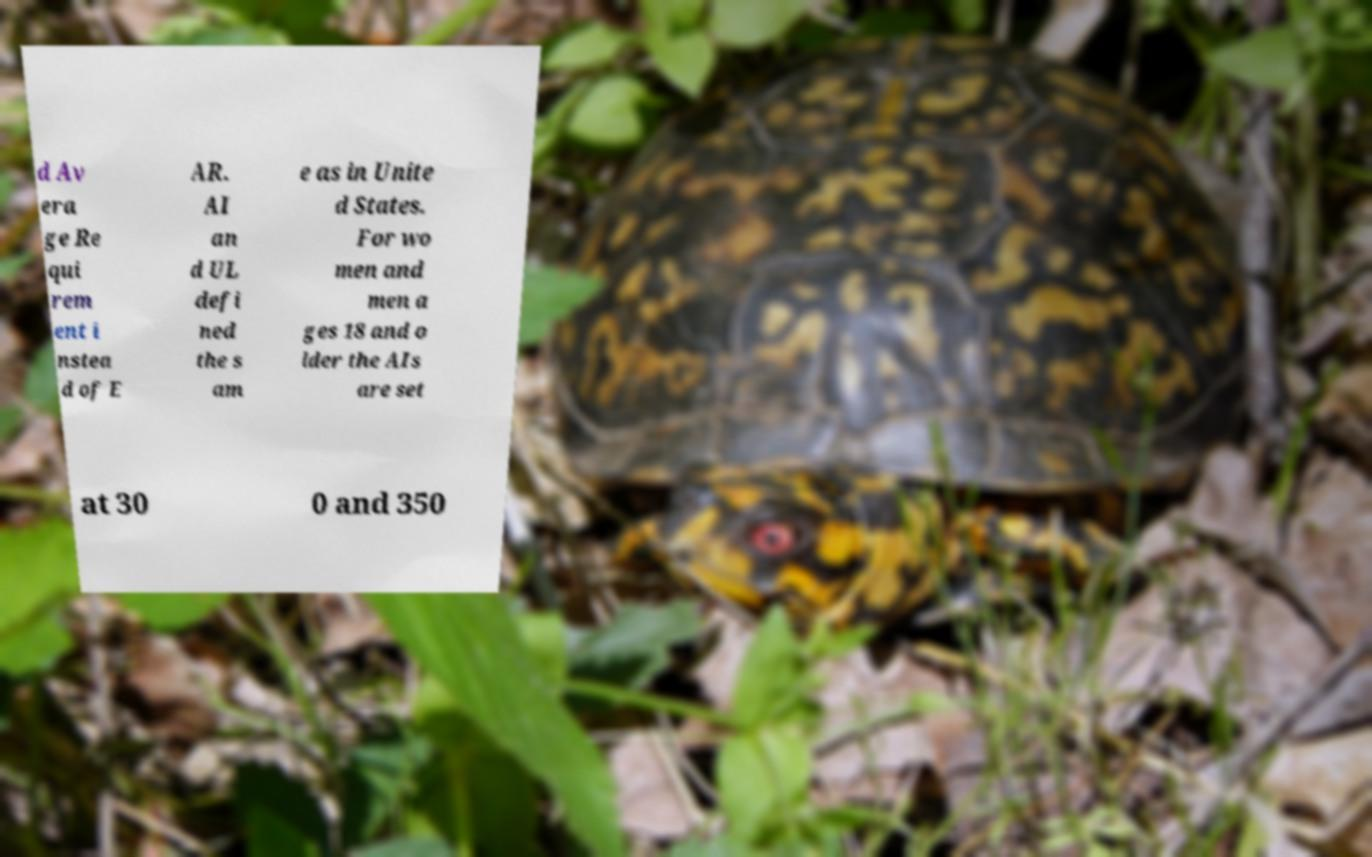Can you accurately transcribe the text from the provided image for me? d Av era ge Re qui rem ent i nstea d of E AR. AI an d UL defi ned the s am e as in Unite d States. For wo men and men a ges 18 and o lder the AIs are set at 30 0 and 350 